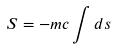<formula> <loc_0><loc_0><loc_500><loc_500>S = - m c \int d s</formula> 